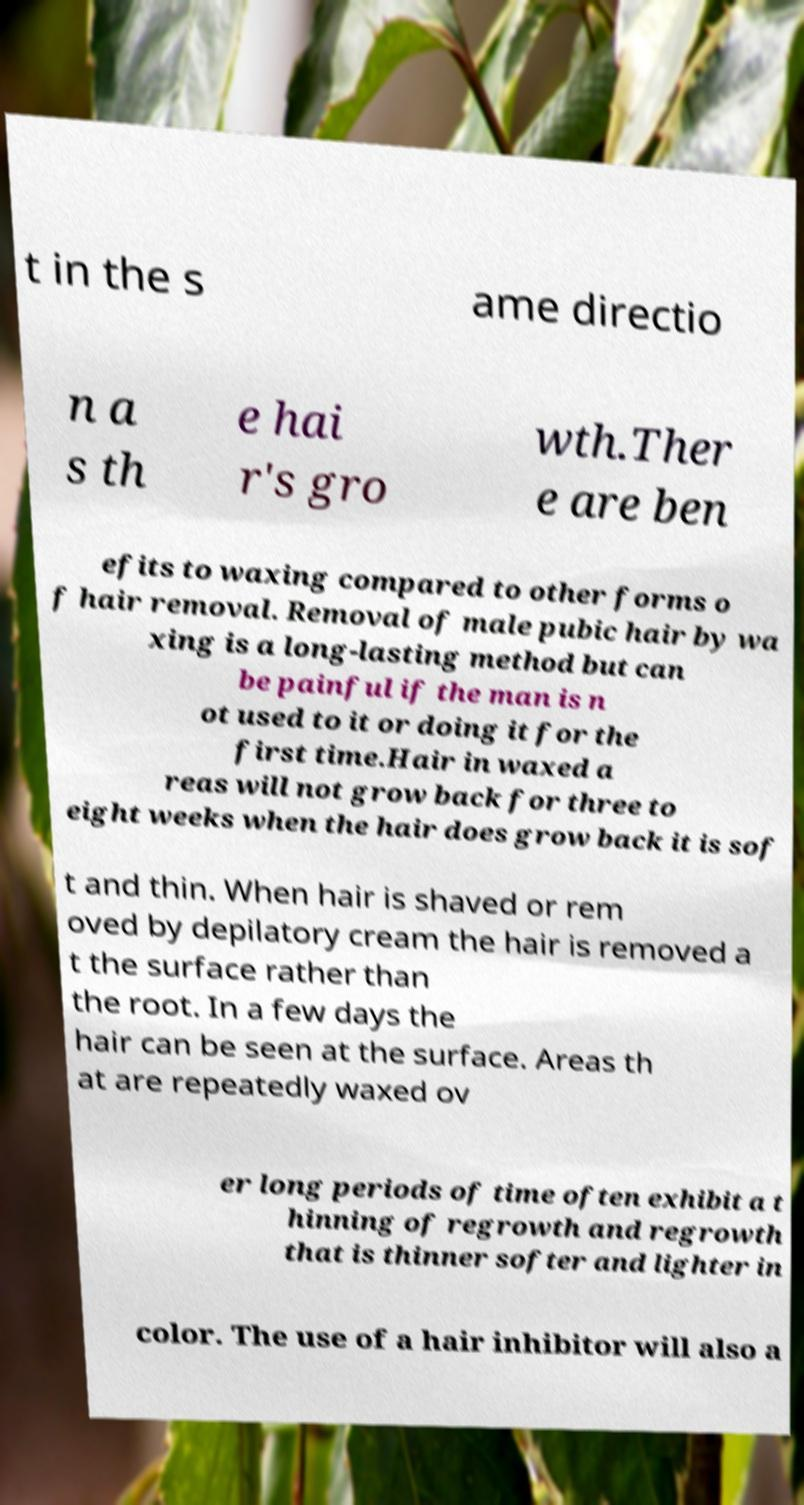What messages or text are displayed in this image? I need them in a readable, typed format. t in the s ame directio n a s th e hai r's gro wth.Ther e are ben efits to waxing compared to other forms o f hair removal. Removal of male pubic hair by wa xing is a long-lasting method but can be painful if the man is n ot used to it or doing it for the first time.Hair in waxed a reas will not grow back for three to eight weeks when the hair does grow back it is sof t and thin. When hair is shaved or rem oved by depilatory cream the hair is removed a t the surface rather than the root. In a few days the hair can be seen at the surface. Areas th at are repeatedly waxed ov er long periods of time often exhibit a t hinning of regrowth and regrowth that is thinner softer and lighter in color. The use of a hair inhibitor will also a 